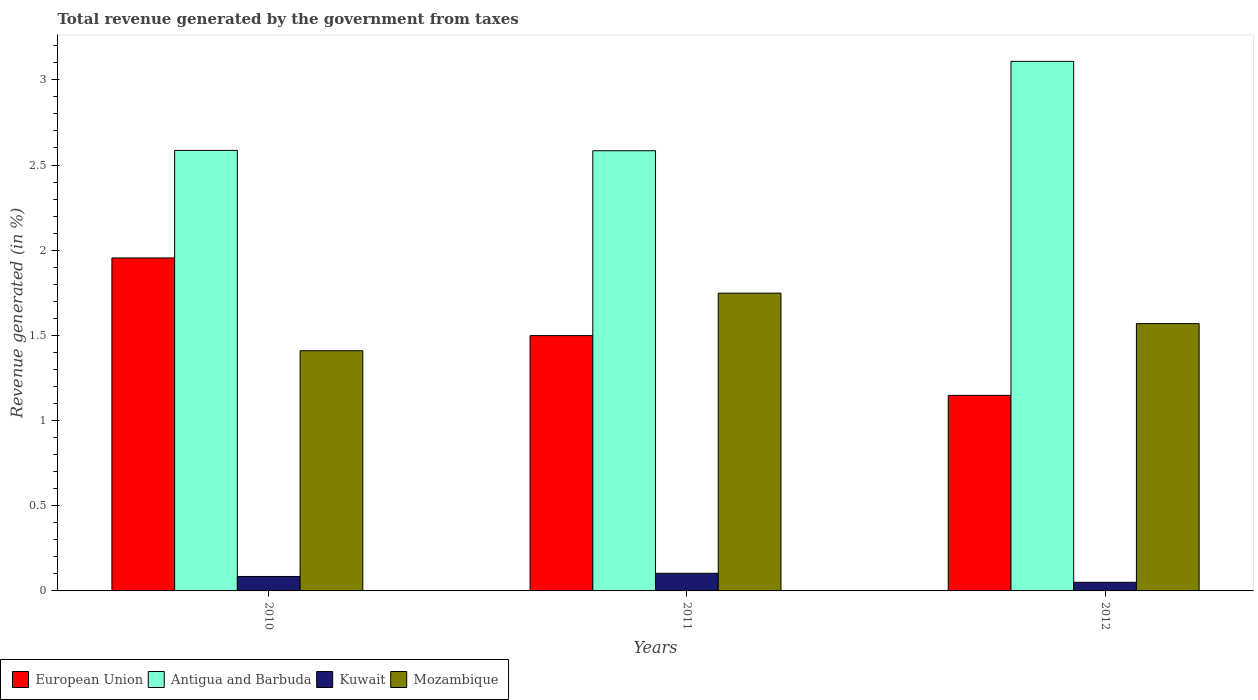How many different coloured bars are there?
Your answer should be compact. 4. Are the number of bars on each tick of the X-axis equal?
Your answer should be very brief. Yes. How many bars are there on the 2nd tick from the right?
Keep it short and to the point. 4. In how many cases, is the number of bars for a given year not equal to the number of legend labels?
Make the answer very short. 0. What is the total revenue generated in Mozambique in 2010?
Make the answer very short. 1.41. Across all years, what is the maximum total revenue generated in Kuwait?
Provide a short and direct response. 0.1. Across all years, what is the minimum total revenue generated in Kuwait?
Provide a succinct answer. 0.05. What is the total total revenue generated in Mozambique in the graph?
Offer a very short reply. 4.73. What is the difference between the total revenue generated in European Union in 2010 and that in 2012?
Your answer should be very brief. 0.81. What is the difference between the total revenue generated in Kuwait in 2010 and the total revenue generated in European Union in 2012?
Offer a very short reply. -1.06. What is the average total revenue generated in Antigua and Barbuda per year?
Offer a terse response. 2.76. In the year 2012, what is the difference between the total revenue generated in Mozambique and total revenue generated in Kuwait?
Ensure brevity in your answer.  1.52. What is the ratio of the total revenue generated in European Union in 2011 to that in 2012?
Provide a succinct answer. 1.31. Is the total revenue generated in Antigua and Barbuda in 2010 less than that in 2011?
Give a very brief answer. No. Is the difference between the total revenue generated in Mozambique in 2010 and 2011 greater than the difference between the total revenue generated in Kuwait in 2010 and 2011?
Make the answer very short. No. What is the difference between the highest and the second highest total revenue generated in Kuwait?
Give a very brief answer. 0.02. What is the difference between the highest and the lowest total revenue generated in Mozambique?
Give a very brief answer. 0.34. Is it the case that in every year, the sum of the total revenue generated in Kuwait and total revenue generated in European Union is greater than the sum of total revenue generated in Antigua and Barbuda and total revenue generated in Mozambique?
Ensure brevity in your answer.  Yes. What does the 4th bar from the left in 2012 represents?
Keep it short and to the point. Mozambique. What does the 3rd bar from the right in 2010 represents?
Keep it short and to the point. Antigua and Barbuda. How many years are there in the graph?
Ensure brevity in your answer.  3. What is the title of the graph?
Keep it short and to the point. Total revenue generated by the government from taxes. Does "World" appear as one of the legend labels in the graph?
Provide a short and direct response. No. What is the label or title of the X-axis?
Your answer should be compact. Years. What is the label or title of the Y-axis?
Keep it short and to the point. Revenue generated (in %). What is the Revenue generated (in %) of European Union in 2010?
Your answer should be compact. 1.95. What is the Revenue generated (in %) of Antigua and Barbuda in 2010?
Your response must be concise. 2.59. What is the Revenue generated (in %) of Kuwait in 2010?
Offer a terse response. 0.08. What is the Revenue generated (in %) of Mozambique in 2010?
Provide a succinct answer. 1.41. What is the Revenue generated (in %) of European Union in 2011?
Give a very brief answer. 1.5. What is the Revenue generated (in %) of Antigua and Barbuda in 2011?
Offer a very short reply. 2.58. What is the Revenue generated (in %) of Kuwait in 2011?
Offer a very short reply. 0.1. What is the Revenue generated (in %) in Mozambique in 2011?
Make the answer very short. 1.75. What is the Revenue generated (in %) of European Union in 2012?
Offer a very short reply. 1.15. What is the Revenue generated (in %) in Antigua and Barbuda in 2012?
Provide a succinct answer. 3.11. What is the Revenue generated (in %) of Kuwait in 2012?
Your answer should be compact. 0.05. What is the Revenue generated (in %) of Mozambique in 2012?
Give a very brief answer. 1.57. Across all years, what is the maximum Revenue generated (in %) of European Union?
Your answer should be very brief. 1.95. Across all years, what is the maximum Revenue generated (in %) of Antigua and Barbuda?
Your answer should be compact. 3.11. Across all years, what is the maximum Revenue generated (in %) in Kuwait?
Offer a terse response. 0.1. Across all years, what is the maximum Revenue generated (in %) of Mozambique?
Provide a succinct answer. 1.75. Across all years, what is the minimum Revenue generated (in %) of European Union?
Your answer should be very brief. 1.15. Across all years, what is the minimum Revenue generated (in %) in Antigua and Barbuda?
Your answer should be compact. 2.58. Across all years, what is the minimum Revenue generated (in %) of Kuwait?
Your response must be concise. 0.05. Across all years, what is the minimum Revenue generated (in %) in Mozambique?
Give a very brief answer. 1.41. What is the total Revenue generated (in %) in European Union in the graph?
Offer a terse response. 4.6. What is the total Revenue generated (in %) in Antigua and Barbuda in the graph?
Provide a short and direct response. 8.28. What is the total Revenue generated (in %) of Kuwait in the graph?
Your answer should be compact. 0.24. What is the total Revenue generated (in %) in Mozambique in the graph?
Make the answer very short. 4.73. What is the difference between the Revenue generated (in %) in European Union in 2010 and that in 2011?
Provide a succinct answer. 0.46. What is the difference between the Revenue generated (in %) in Antigua and Barbuda in 2010 and that in 2011?
Provide a succinct answer. 0. What is the difference between the Revenue generated (in %) in Kuwait in 2010 and that in 2011?
Provide a short and direct response. -0.02. What is the difference between the Revenue generated (in %) of Mozambique in 2010 and that in 2011?
Ensure brevity in your answer.  -0.34. What is the difference between the Revenue generated (in %) in European Union in 2010 and that in 2012?
Offer a terse response. 0.81. What is the difference between the Revenue generated (in %) of Antigua and Barbuda in 2010 and that in 2012?
Offer a terse response. -0.52. What is the difference between the Revenue generated (in %) of Kuwait in 2010 and that in 2012?
Ensure brevity in your answer.  0.03. What is the difference between the Revenue generated (in %) of Mozambique in 2010 and that in 2012?
Provide a succinct answer. -0.16. What is the difference between the Revenue generated (in %) of European Union in 2011 and that in 2012?
Offer a very short reply. 0.35. What is the difference between the Revenue generated (in %) in Antigua and Barbuda in 2011 and that in 2012?
Offer a very short reply. -0.52. What is the difference between the Revenue generated (in %) in Kuwait in 2011 and that in 2012?
Keep it short and to the point. 0.05. What is the difference between the Revenue generated (in %) in Mozambique in 2011 and that in 2012?
Make the answer very short. 0.18. What is the difference between the Revenue generated (in %) in European Union in 2010 and the Revenue generated (in %) in Antigua and Barbuda in 2011?
Your answer should be compact. -0.63. What is the difference between the Revenue generated (in %) in European Union in 2010 and the Revenue generated (in %) in Kuwait in 2011?
Give a very brief answer. 1.85. What is the difference between the Revenue generated (in %) of European Union in 2010 and the Revenue generated (in %) of Mozambique in 2011?
Offer a very short reply. 0.21. What is the difference between the Revenue generated (in %) in Antigua and Barbuda in 2010 and the Revenue generated (in %) in Kuwait in 2011?
Provide a succinct answer. 2.48. What is the difference between the Revenue generated (in %) of Antigua and Barbuda in 2010 and the Revenue generated (in %) of Mozambique in 2011?
Offer a terse response. 0.84. What is the difference between the Revenue generated (in %) of Kuwait in 2010 and the Revenue generated (in %) of Mozambique in 2011?
Offer a terse response. -1.66. What is the difference between the Revenue generated (in %) in European Union in 2010 and the Revenue generated (in %) in Antigua and Barbuda in 2012?
Provide a succinct answer. -1.15. What is the difference between the Revenue generated (in %) of European Union in 2010 and the Revenue generated (in %) of Kuwait in 2012?
Your answer should be very brief. 1.9. What is the difference between the Revenue generated (in %) in European Union in 2010 and the Revenue generated (in %) in Mozambique in 2012?
Provide a short and direct response. 0.39. What is the difference between the Revenue generated (in %) of Antigua and Barbuda in 2010 and the Revenue generated (in %) of Kuwait in 2012?
Make the answer very short. 2.54. What is the difference between the Revenue generated (in %) of Antigua and Barbuda in 2010 and the Revenue generated (in %) of Mozambique in 2012?
Offer a very short reply. 1.02. What is the difference between the Revenue generated (in %) in Kuwait in 2010 and the Revenue generated (in %) in Mozambique in 2012?
Give a very brief answer. -1.48. What is the difference between the Revenue generated (in %) in European Union in 2011 and the Revenue generated (in %) in Antigua and Barbuda in 2012?
Make the answer very short. -1.61. What is the difference between the Revenue generated (in %) of European Union in 2011 and the Revenue generated (in %) of Kuwait in 2012?
Offer a terse response. 1.45. What is the difference between the Revenue generated (in %) in European Union in 2011 and the Revenue generated (in %) in Mozambique in 2012?
Give a very brief answer. -0.07. What is the difference between the Revenue generated (in %) in Antigua and Barbuda in 2011 and the Revenue generated (in %) in Kuwait in 2012?
Your response must be concise. 2.53. What is the difference between the Revenue generated (in %) of Antigua and Barbuda in 2011 and the Revenue generated (in %) of Mozambique in 2012?
Your answer should be compact. 1.01. What is the difference between the Revenue generated (in %) in Kuwait in 2011 and the Revenue generated (in %) in Mozambique in 2012?
Offer a very short reply. -1.47. What is the average Revenue generated (in %) of European Union per year?
Keep it short and to the point. 1.53. What is the average Revenue generated (in %) in Antigua and Barbuda per year?
Provide a succinct answer. 2.76. What is the average Revenue generated (in %) in Kuwait per year?
Your answer should be very brief. 0.08. What is the average Revenue generated (in %) of Mozambique per year?
Your answer should be compact. 1.58. In the year 2010, what is the difference between the Revenue generated (in %) of European Union and Revenue generated (in %) of Antigua and Barbuda?
Your answer should be very brief. -0.63. In the year 2010, what is the difference between the Revenue generated (in %) in European Union and Revenue generated (in %) in Kuwait?
Your answer should be very brief. 1.87. In the year 2010, what is the difference between the Revenue generated (in %) of European Union and Revenue generated (in %) of Mozambique?
Offer a terse response. 0.54. In the year 2010, what is the difference between the Revenue generated (in %) in Antigua and Barbuda and Revenue generated (in %) in Kuwait?
Keep it short and to the point. 2.5. In the year 2010, what is the difference between the Revenue generated (in %) in Antigua and Barbuda and Revenue generated (in %) in Mozambique?
Your response must be concise. 1.18. In the year 2010, what is the difference between the Revenue generated (in %) of Kuwait and Revenue generated (in %) of Mozambique?
Offer a terse response. -1.33. In the year 2011, what is the difference between the Revenue generated (in %) in European Union and Revenue generated (in %) in Antigua and Barbuda?
Your answer should be very brief. -1.09. In the year 2011, what is the difference between the Revenue generated (in %) in European Union and Revenue generated (in %) in Kuwait?
Give a very brief answer. 1.4. In the year 2011, what is the difference between the Revenue generated (in %) of European Union and Revenue generated (in %) of Mozambique?
Offer a very short reply. -0.25. In the year 2011, what is the difference between the Revenue generated (in %) in Antigua and Barbuda and Revenue generated (in %) in Kuwait?
Give a very brief answer. 2.48. In the year 2011, what is the difference between the Revenue generated (in %) in Antigua and Barbuda and Revenue generated (in %) in Mozambique?
Ensure brevity in your answer.  0.84. In the year 2011, what is the difference between the Revenue generated (in %) of Kuwait and Revenue generated (in %) of Mozambique?
Keep it short and to the point. -1.64. In the year 2012, what is the difference between the Revenue generated (in %) of European Union and Revenue generated (in %) of Antigua and Barbuda?
Your response must be concise. -1.96. In the year 2012, what is the difference between the Revenue generated (in %) of European Union and Revenue generated (in %) of Kuwait?
Offer a terse response. 1.1. In the year 2012, what is the difference between the Revenue generated (in %) in European Union and Revenue generated (in %) in Mozambique?
Your answer should be very brief. -0.42. In the year 2012, what is the difference between the Revenue generated (in %) of Antigua and Barbuda and Revenue generated (in %) of Kuwait?
Make the answer very short. 3.06. In the year 2012, what is the difference between the Revenue generated (in %) in Antigua and Barbuda and Revenue generated (in %) in Mozambique?
Offer a very short reply. 1.54. In the year 2012, what is the difference between the Revenue generated (in %) of Kuwait and Revenue generated (in %) of Mozambique?
Make the answer very short. -1.52. What is the ratio of the Revenue generated (in %) of European Union in 2010 to that in 2011?
Provide a short and direct response. 1.3. What is the ratio of the Revenue generated (in %) of Antigua and Barbuda in 2010 to that in 2011?
Your answer should be very brief. 1. What is the ratio of the Revenue generated (in %) of Kuwait in 2010 to that in 2011?
Keep it short and to the point. 0.82. What is the ratio of the Revenue generated (in %) in Mozambique in 2010 to that in 2011?
Keep it short and to the point. 0.81. What is the ratio of the Revenue generated (in %) in European Union in 2010 to that in 2012?
Your answer should be very brief. 1.7. What is the ratio of the Revenue generated (in %) in Antigua and Barbuda in 2010 to that in 2012?
Your answer should be compact. 0.83. What is the ratio of the Revenue generated (in %) of Kuwait in 2010 to that in 2012?
Offer a terse response. 1.68. What is the ratio of the Revenue generated (in %) of Mozambique in 2010 to that in 2012?
Provide a short and direct response. 0.9. What is the ratio of the Revenue generated (in %) in European Union in 2011 to that in 2012?
Your answer should be compact. 1.31. What is the ratio of the Revenue generated (in %) in Antigua and Barbuda in 2011 to that in 2012?
Offer a terse response. 0.83. What is the ratio of the Revenue generated (in %) of Kuwait in 2011 to that in 2012?
Provide a short and direct response. 2.05. What is the ratio of the Revenue generated (in %) of Mozambique in 2011 to that in 2012?
Your answer should be compact. 1.11. What is the difference between the highest and the second highest Revenue generated (in %) of European Union?
Provide a succinct answer. 0.46. What is the difference between the highest and the second highest Revenue generated (in %) of Antigua and Barbuda?
Make the answer very short. 0.52. What is the difference between the highest and the second highest Revenue generated (in %) of Kuwait?
Offer a terse response. 0.02. What is the difference between the highest and the second highest Revenue generated (in %) of Mozambique?
Provide a short and direct response. 0.18. What is the difference between the highest and the lowest Revenue generated (in %) in European Union?
Your answer should be very brief. 0.81. What is the difference between the highest and the lowest Revenue generated (in %) in Antigua and Barbuda?
Make the answer very short. 0.52. What is the difference between the highest and the lowest Revenue generated (in %) of Kuwait?
Provide a short and direct response. 0.05. What is the difference between the highest and the lowest Revenue generated (in %) in Mozambique?
Your answer should be compact. 0.34. 